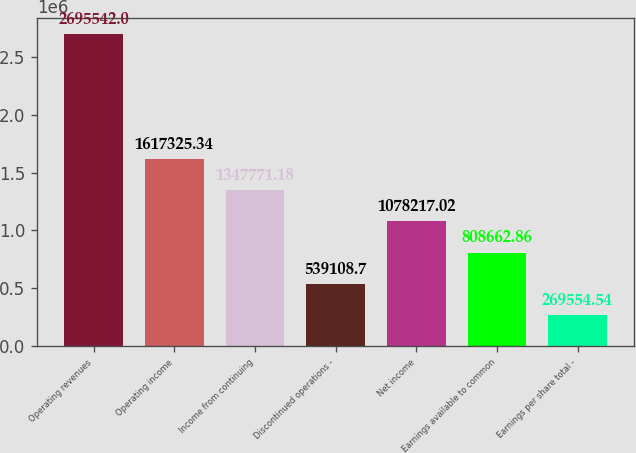Convert chart. <chart><loc_0><loc_0><loc_500><loc_500><bar_chart><fcel>Operating revenues<fcel>Operating income<fcel>Income from continuing<fcel>Discontinued operations -<fcel>Net income<fcel>Earnings available to common<fcel>Earnings per share total -<nl><fcel>2.69554e+06<fcel>1.61733e+06<fcel>1.34777e+06<fcel>539109<fcel>1.07822e+06<fcel>808663<fcel>269555<nl></chart> 